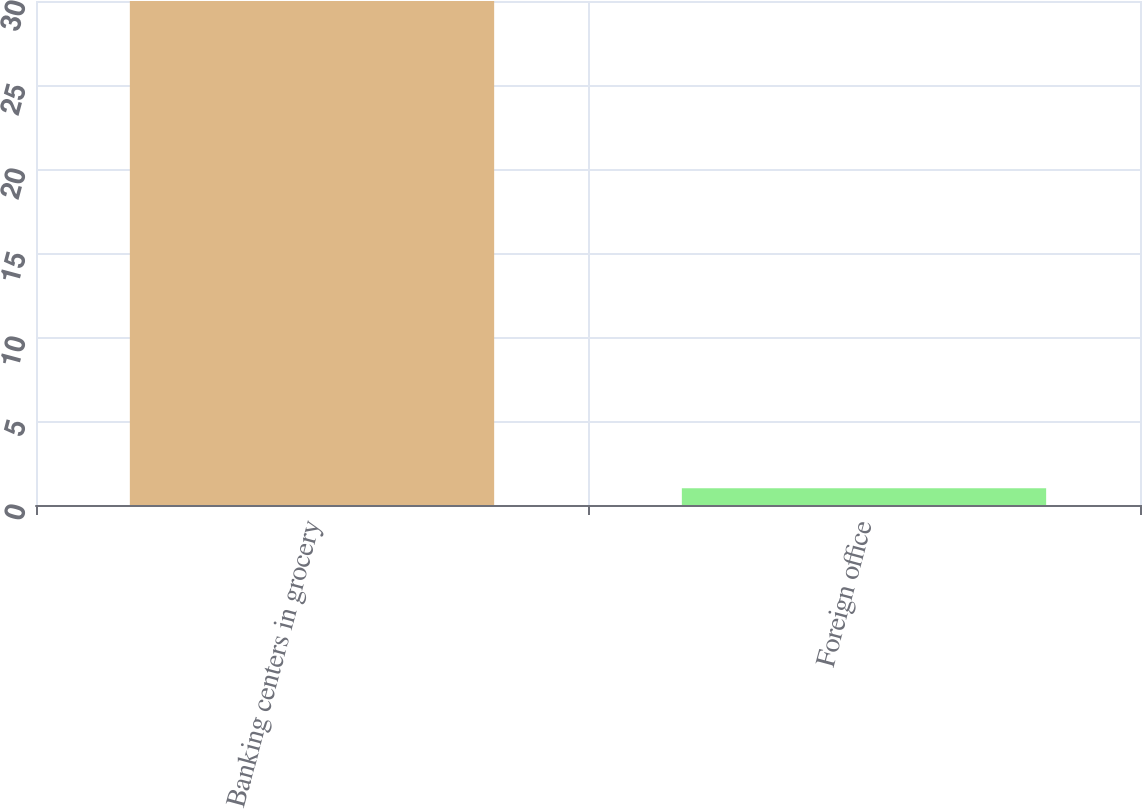<chart> <loc_0><loc_0><loc_500><loc_500><bar_chart><fcel>Banking centers in grocery<fcel>Foreign office<nl><fcel>30<fcel>1<nl></chart> 